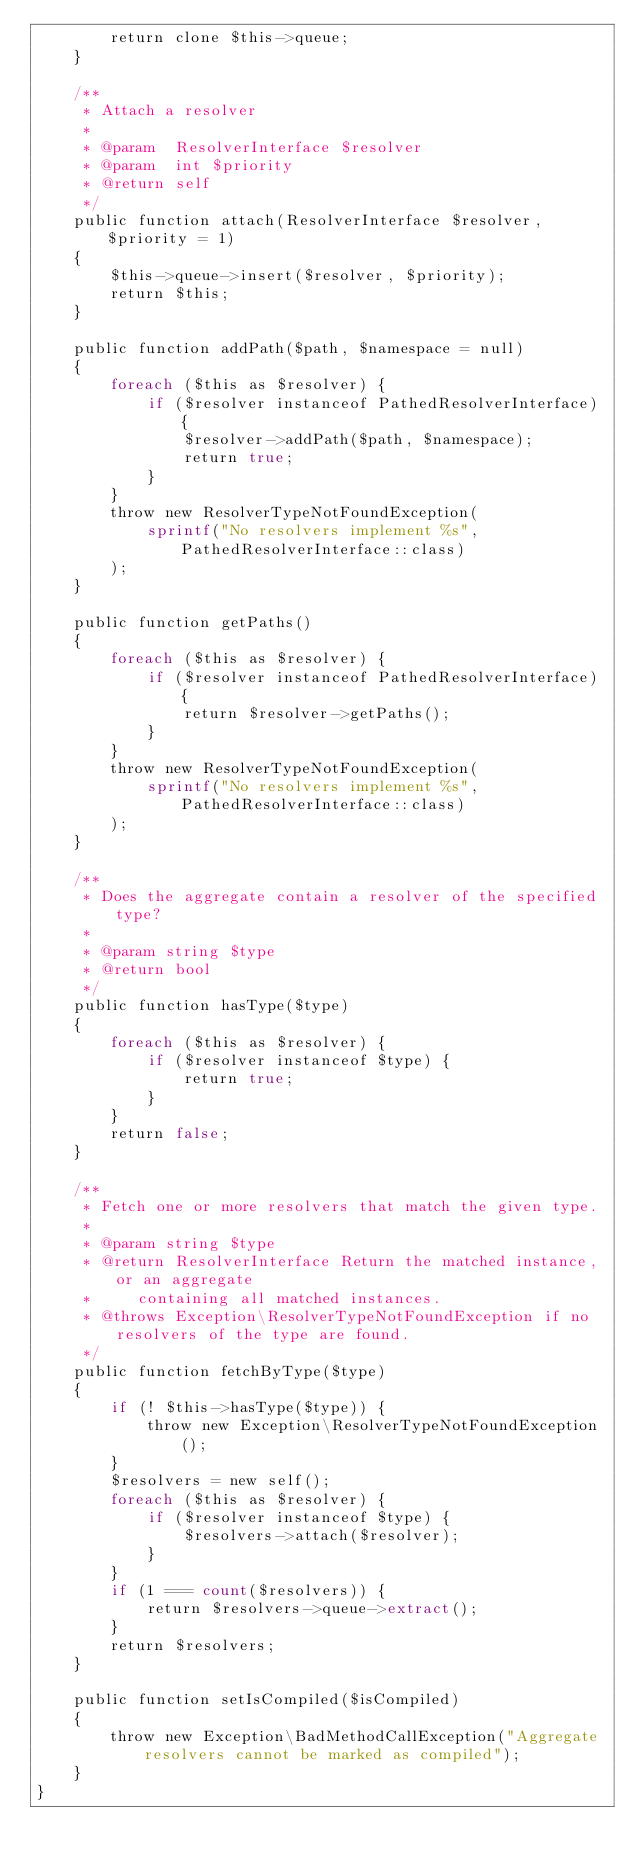<code> <loc_0><loc_0><loc_500><loc_500><_PHP_>        return clone $this->queue;
    }

    /**
     * Attach a resolver
     *
     * @param  ResolverInterface $resolver
     * @param  int $priority
     * @return self
     */
    public function attach(ResolverInterface $resolver, $priority = 1)
    {
        $this->queue->insert($resolver, $priority);
        return $this;
    }

    public function addPath($path, $namespace = null)
    {
        foreach ($this as $resolver) {
            if ($resolver instanceof PathedResolverInterface) {
                $resolver->addPath($path, $namespace);
                return true;
            }
        }
        throw new ResolverTypeNotFoundException(
            sprintf("No resolvers implement %s", PathedResolverInterface::class)
        );
    }

    public function getPaths()
    {
        foreach ($this as $resolver) {
            if ($resolver instanceof PathedResolverInterface) {
                return $resolver->getPaths();
            }
        }
        throw new ResolverTypeNotFoundException(
            sprintf("No resolvers implement %s", PathedResolverInterface::class)
        );
    }

    /**
     * Does the aggregate contain a resolver of the specified type?
     *
     * @param string $type
     * @return bool
     */
    public function hasType($type)
    {
        foreach ($this as $resolver) {
            if ($resolver instanceof $type) {
                return true;
            }
        }
        return false;
    }

    /**
     * Fetch one or more resolvers that match the given type.
     *
     * @param string $type
     * @return ResolverInterface Return the matched instance, or an aggregate
     *     containing all matched instances.
     * @throws Exception\ResolverTypeNotFoundException if no resolvers of the type are found.
     */
    public function fetchByType($type)
    {
        if (! $this->hasType($type)) {
            throw new Exception\ResolverTypeNotFoundException();
        }
        $resolvers = new self();
        foreach ($this as $resolver) {
            if ($resolver instanceof $type) {
                $resolvers->attach($resolver);
            }
        }
        if (1 === count($resolvers)) {
            return $resolvers->queue->extract();
        }
        return $resolvers;
    }

    public function setIsCompiled($isCompiled)
    {
        throw new Exception\BadMethodCallException("Aggregate resolvers cannot be marked as compiled");
    }
}
</code> 